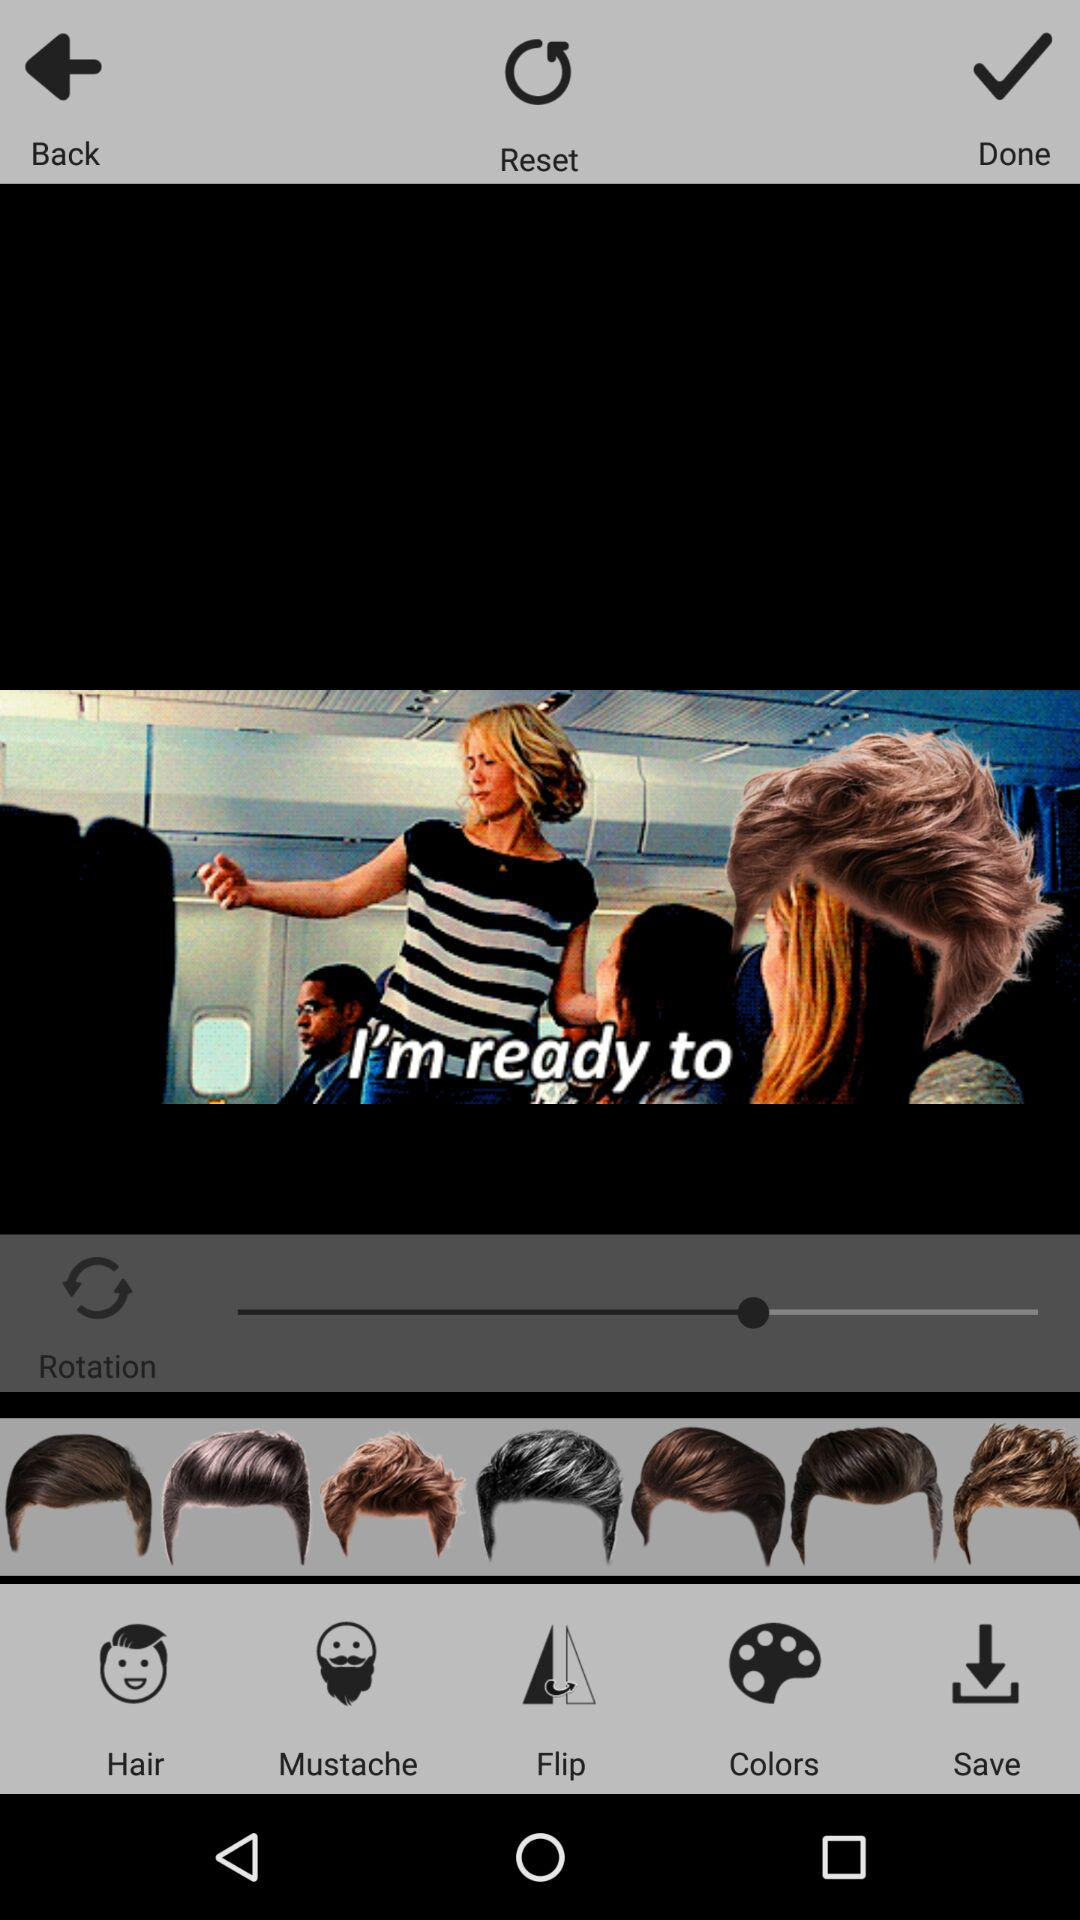How many more hairstyles are there than facial hair options?
Answer the question using a single word or phrase. 7 